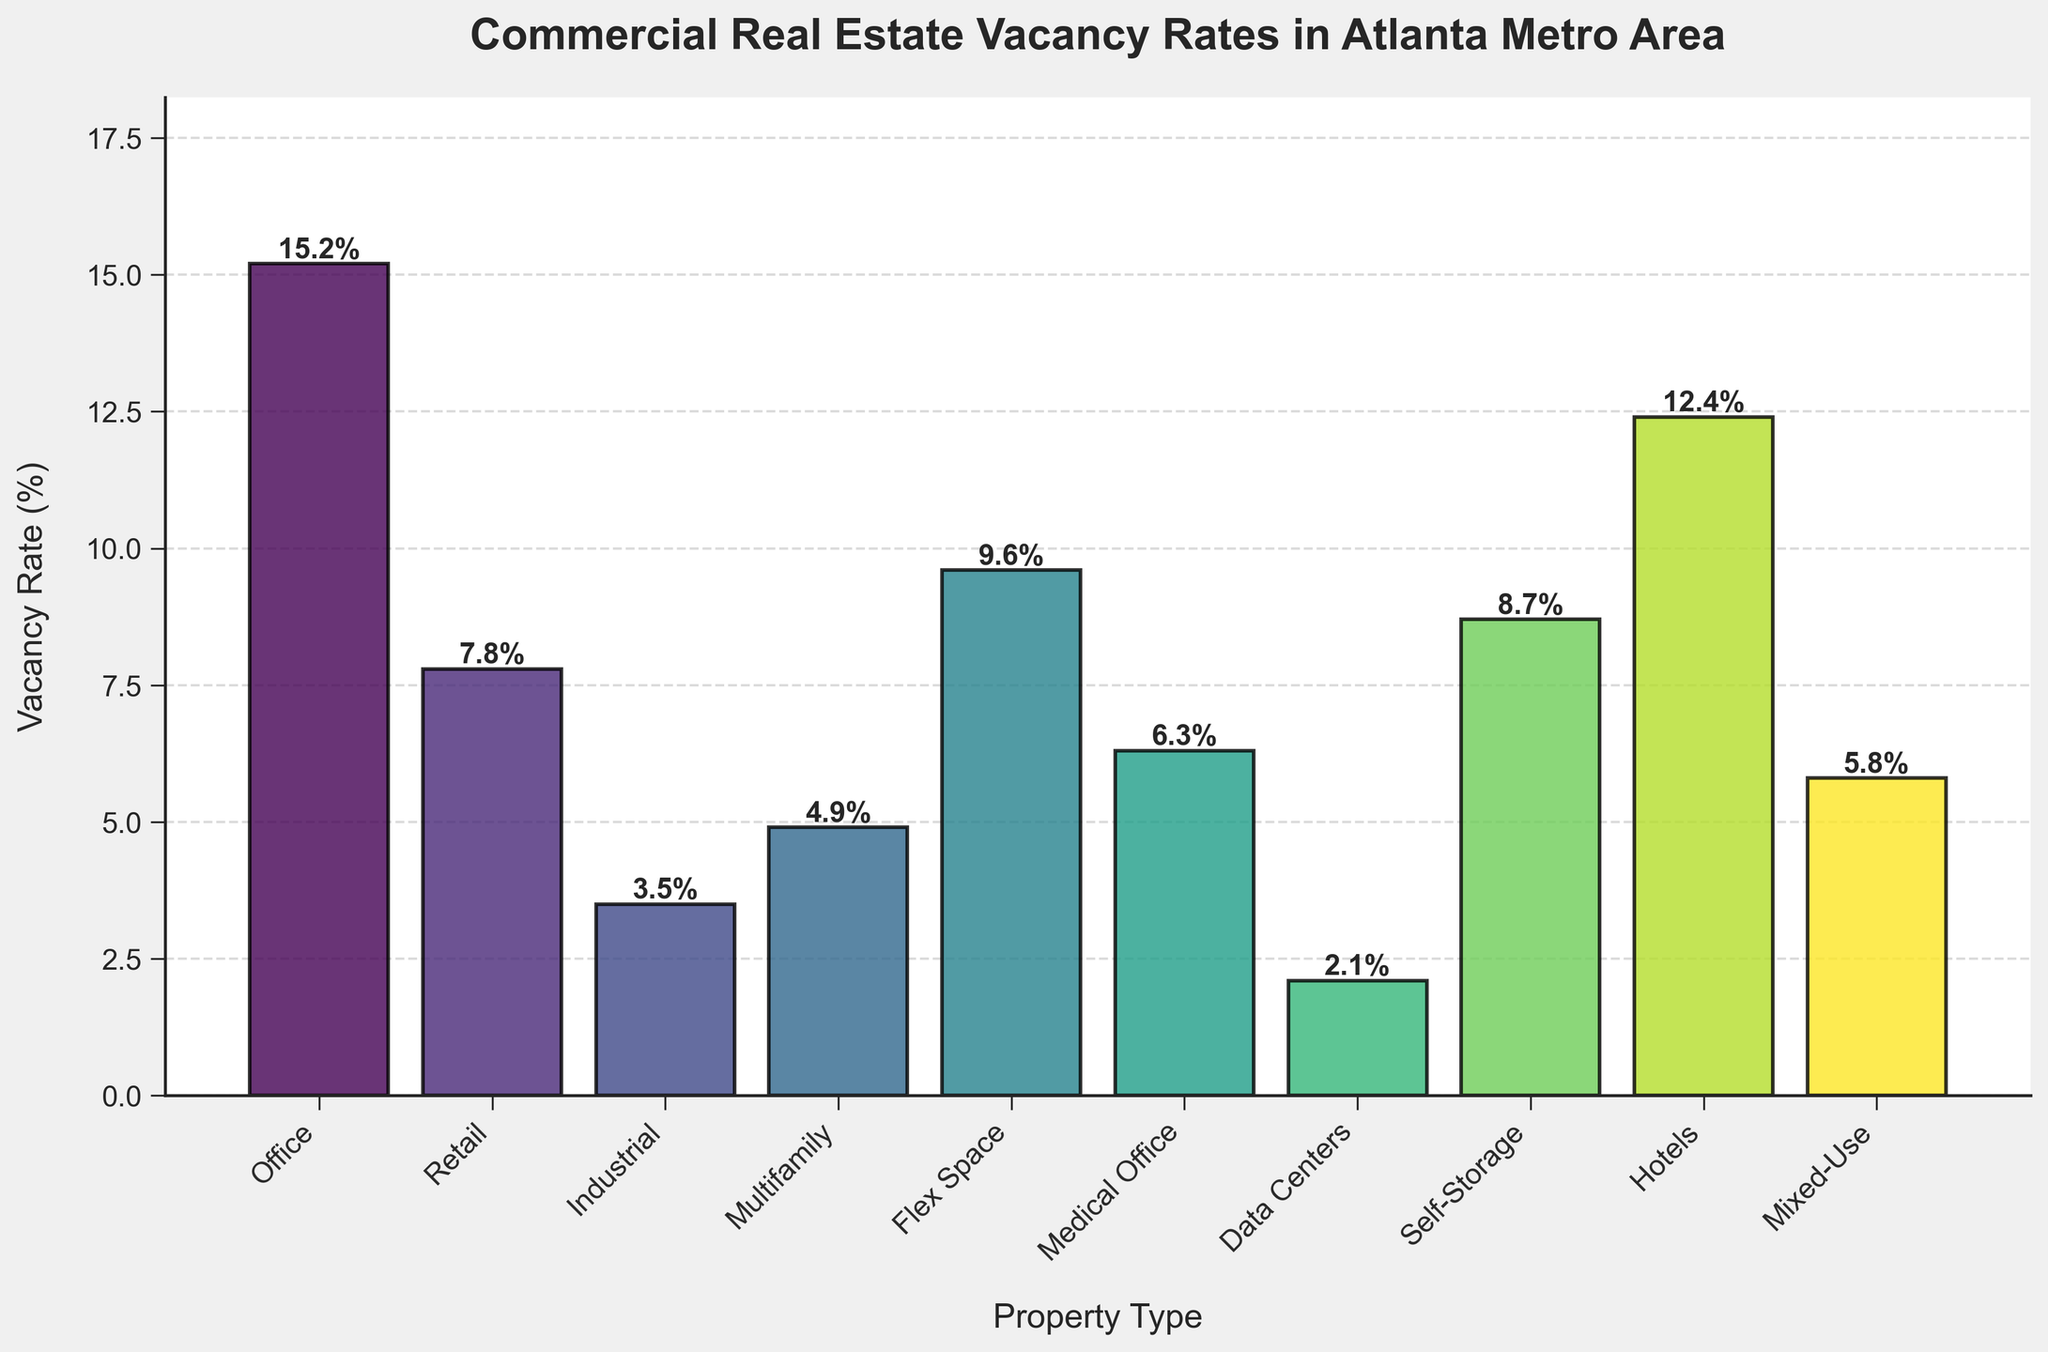What is the property type with the highest vacancy rate? Looking at the heights of the bars, 'Office' has the highest bar reaching 15.2%.
Answer: Office Which property type has a vacancy rate lower than 5%? By examining the heights of the bars, 'Industrial' (3.5%), 'Multifamily' (4.9%), and 'Data Centers' (2.1%) all have bars lower than the 5% mark.
Answer: Industrial, Multifamily, Data Centers Is the vacancy rate of Flex Space higher or lower than Self-Storage? Comparing the heights of the bars, the vacancy rate of Flex Space (9.6%) is higher than that of Self-Storage (8.7%).
Answer: Higher What is the combined vacancy rate of Retail and Hotels? The vacancy rate of Retail is 7.8%, and for Hotels, it is 12.4%. Adding these together: 7.8 + 12.4 = 20.2%.
Answer: 20.2% What is the average vacancy rate of all property types? Summing all vacancy rates: 15.2 + 7.8 + 3.5 + 4.9 + 9.6 + 6.3 + 2.1 + 8.7 + 12.4 + 5.8 = 76.3. Divide by the number of types (10): 76.3 / 10 = 7.63%.
Answer: 7.63% Which property types have a vacancy rate above 10%? Looking at the height of the bars, 'Office' (15.2%) and 'Hotels' (12.4%) have bars above the 10% mark.
Answer: Office, Hotels How much is the vacancy rate difference between the property type with the highest rate and the one with the lowest? The property type with the highest vacancy rate is 'Office' at 15.2%, and the lowest is 'Data Centers' at 2.1%. Subtracting these: 15.2 - 2.1 = 13.1%.
Answer: 13.1% What is the median vacancy rate? Ordering the vacancy rates: 2.1, 3.5, 4.9, 5.8, 6.3, 7.8, 8.7, 9.6, 12.4, 15.2. The median value is the average of the 5th and 6th values: (6.3 + 7.8) / 2 = 7.05%.
Answer: 7.05% Which property type's vacancy rate is closest to the average vacancy rate? The average vacancy rate is 7.63%. The closest vacancy rates are Retail (7.8%) and Medical Office (6.3%). Retail is closer to the average.
Answer: Retail Does Mixed-Use have a higher or lower vacancy rate compared to Medical Office? Comparing the heights of the bars, 'Mixed-Use' (5.8%) has a slightly lower vacancy rate than 'Medical Office' (6.3%).
Answer: Lower 